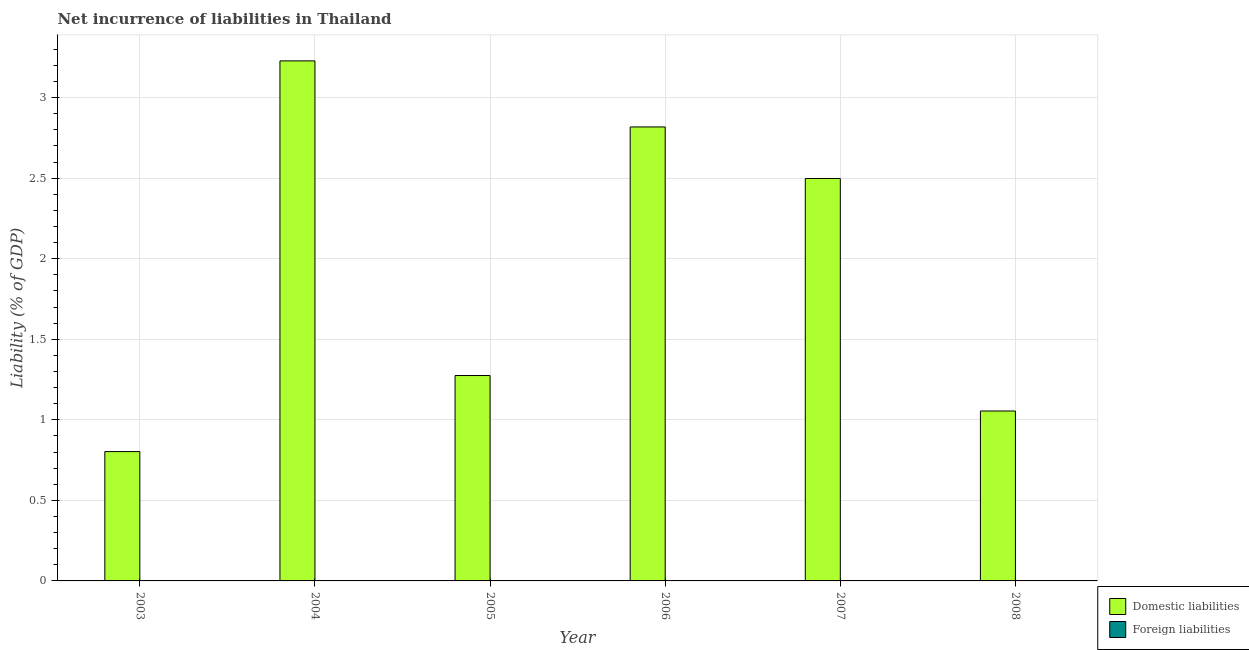Are the number of bars on each tick of the X-axis equal?
Your answer should be compact. Yes. How many bars are there on the 1st tick from the left?
Give a very brief answer. 1. What is the label of the 3rd group of bars from the left?
Offer a very short reply. 2005. What is the incurrence of domestic liabilities in 2008?
Give a very brief answer. 1.05. Across all years, what is the maximum incurrence of domestic liabilities?
Give a very brief answer. 3.23. Across all years, what is the minimum incurrence of foreign liabilities?
Your answer should be compact. 0. What is the total incurrence of domestic liabilities in the graph?
Provide a short and direct response. 11.68. What is the difference between the incurrence of domestic liabilities in 2003 and that in 2005?
Your response must be concise. -0.47. What is the difference between the incurrence of foreign liabilities in 2005 and the incurrence of domestic liabilities in 2007?
Provide a succinct answer. 0. What is the average incurrence of foreign liabilities per year?
Your answer should be compact. 0. In how many years, is the incurrence of foreign liabilities greater than 2.2 %?
Provide a short and direct response. 0. What is the ratio of the incurrence of domestic liabilities in 2006 to that in 2008?
Offer a terse response. 2.67. Is the incurrence of domestic liabilities in 2007 less than that in 2008?
Offer a terse response. No. Is the difference between the incurrence of domestic liabilities in 2003 and 2004 greater than the difference between the incurrence of foreign liabilities in 2003 and 2004?
Keep it short and to the point. No. What is the difference between the highest and the second highest incurrence of domestic liabilities?
Make the answer very short. 0.41. What is the difference between the highest and the lowest incurrence of domestic liabilities?
Offer a very short reply. 2.43. Is the sum of the incurrence of domestic liabilities in 2006 and 2007 greater than the maximum incurrence of foreign liabilities across all years?
Offer a very short reply. Yes. How many years are there in the graph?
Keep it short and to the point. 6. What is the difference between two consecutive major ticks on the Y-axis?
Give a very brief answer. 0.5. Does the graph contain any zero values?
Your answer should be very brief. Yes. Does the graph contain grids?
Your response must be concise. Yes. What is the title of the graph?
Provide a succinct answer. Net incurrence of liabilities in Thailand. What is the label or title of the X-axis?
Provide a short and direct response. Year. What is the label or title of the Y-axis?
Your response must be concise. Liability (% of GDP). What is the Liability (% of GDP) in Domestic liabilities in 2003?
Provide a short and direct response. 0.8. What is the Liability (% of GDP) of Foreign liabilities in 2003?
Ensure brevity in your answer.  0. What is the Liability (% of GDP) of Domestic liabilities in 2004?
Offer a very short reply. 3.23. What is the Liability (% of GDP) in Domestic liabilities in 2005?
Provide a short and direct response. 1.27. What is the Liability (% of GDP) of Foreign liabilities in 2005?
Your answer should be very brief. 0. What is the Liability (% of GDP) in Domestic liabilities in 2006?
Provide a short and direct response. 2.82. What is the Liability (% of GDP) in Foreign liabilities in 2006?
Offer a terse response. 0. What is the Liability (% of GDP) of Domestic liabilities in 2007?
Provide a short and direct response. 2.5. What is the Liability (% of GDP) in Domestic liabilities in 2008?
Ensure brevity in your answer.  1.05. What is the Liability (% of GDP) in Foreign liabilities in 2008?
Make the answer very short. 0. Across all years, what is the maximum Liability (% of GDP) in Domestic liabilities?
Your answer should be very brief. 3.23. Across all years, what is the minimum Liability (% of GDP) in Domestic liabilities?
Provide a succinct answer. 0.8. What is the total Liability (% of GDP) of Domestic liabilities in the graph?
Give a very brief answer. 11.68. What is the total Liability (% of GDP) in Foreign liabilities in the graph?
Offer a very short reply. 0. What is the difference between the Liability (% of GDP) of Domestic liabilities in 2003 and that in 2004?
Your answer should be very brief. -2.43. What is the difference between the Liability (% of GDP) of Domestic liabilities in 2003 and that in 2005?
Your response must be concise. -0.47. What is the difference between the Liability (% of GDP) in Domestic liabilities in 2003 and that in 2006?
Your answer should be very brief. -2.02. What is the difference between the Liability (% of GDP) of Domestic liabilities in 2003 and that in 2007?
Offer a terse response. -1.7. What is the difference between the Liability (% of GDP) in Domestic liabilities in 2003 and that in 2008?
Make the answer very short. -0.25. What is the difference between the Liability (% of GDP) in Domestic liabilities in 2004 and that in 2005?
Offer a very short reply. 1.95. What is the difference between the Liability (% of GDP) of Domestic liabilities in 2004 and that in 2006?
Keep it short and to the point. 0.41. What is the difference between the Liability (% of GDP) of Domestic liabilities in 2004 and that in 2007?
Your answer should be compact. 0.73. What is the difference between the Liability (% of GDP) of Domestic liabilities in 2004 and that in 2008?
Your answer should be compact. 2.17. What is the difference between the Liability (% of GDP) in Domestic liabilities in 2005 and that in 2006?
Provide a short and direct response. -1.54. What is the difference between the Liability (% of GDP) in Domestic liabilities in 2005 and that in 2007?
Your answer should be very brief. -1.22. What is the difference between the Liability (% of GDP) of Domestic liabilities in 2005 and that in 2008?
Your answer should be compact. 0.22. What is the difference between the Liability (% of GDP) in Domestic liabilities in 2006 and that in 2007?
Keep it short and to the point. 0.32. What is the difference between the Liability (% of GDP) in Domestic liabilities in 2006 and that in 2008?
Provide a succinct answer. 1.76. What is the difference between the Liability (% of GDP) of Domestic liabilities in 2007 and that in 2008?
Provide a succinct answer. 1.44. What is the average Liability (% of GDP) in Domestic liabilities per year?
Keep it short and to the point. 1.95. What is the average Liability (% of GDP) in Foreign liabilities per year?
Make the answer very short. 0. What is the ratio of the Liability (% of GDP) of Domestic liabilities in 2003 to that in 2004?
Make the answer very short. 0.25. What is the ratio of the Liability (% of GDP) of Domestic liabilities in 2003 to that in 2005?
Offer a terse response. 0.63. What is the ratio of the Liability (% of GDP) of Domestic liabilities in 2003 to that in 2006?
Your answer should be very brief. 0.28. What is the ratio of the Liability (% of GDP) of Domestic liabilities in 2003 to that in 2007?
Your answer should be very brief. 0.32. What is the ratio of the Liability (% of GDP) of Domestic liabilities in 2003 to that in 2008?
Make the answer very short. 0.76. What is the ratio of the Liability (% of GDP) of Domestic liabilities in 2004 to that in 2005?
Make the answer very short. 2.53. What is the ratio of the Liability (% of GDP) in Domestic liabilities in 2004 to that in 2006?
Your response must be concise. 1.15. What is the ratio of the Liability (% of GDP) in Domestic liabilities in 2004 to that in 2007?
Your answer should be compact. 1.29. What is the ratio of the Liability (% of GDP) in Domestic liabilities in 2004 to that in 2008?
Provide a short and direct response. 3.06. What is the ratio of the Liability (% of GDP) in Domestic liabilities in 2005 to that in 2006?
Your answer should be very brief. 0.45. What is the ratio of the Liability (% of GDP) of Domestic liabilities in 2005 to that in 2007?
Ensure brevity in your answer.  0.51. What is the ratio of the Liability (% of GDP) in Domestic liabilities in 2005 to that in 2008?
Give a very brief answer. 1.21. What is the ratio of the Liability (% of GDP) of Domestic liabilities in 2006 to that in 2007?
Your answer should be compact. 1.13. What is the ratio of the Liability (% of GDP) in Domestic liabilities in 2006 to that in 2008?
Your answer should be very brief. 2.67. What is the ratio of the Liability (% of GDP) in Domestic liabilities in 2007 to that in 2008?
Keep it short and to the point. 2.37. What is the difference between the highest and the second highest Liability (% of GDP) of Domestic liabilities?
Keep it short and to the point. 0.41. What is the difference between the highest and the lowest Liability (% of GDP) in Domestic liabilities?
Your response must be concise. 2.43. 